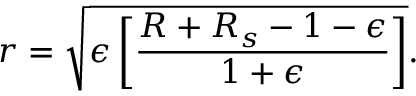Convert formula to latex. <formula><loc_0><loc_0><loc_500><loc_500>r = \sqrt { \epsilon \left [ \frac { R + R _ { s } - 1 - \epsilon } { 1 + \epsilon } \right ] } .</formula> 